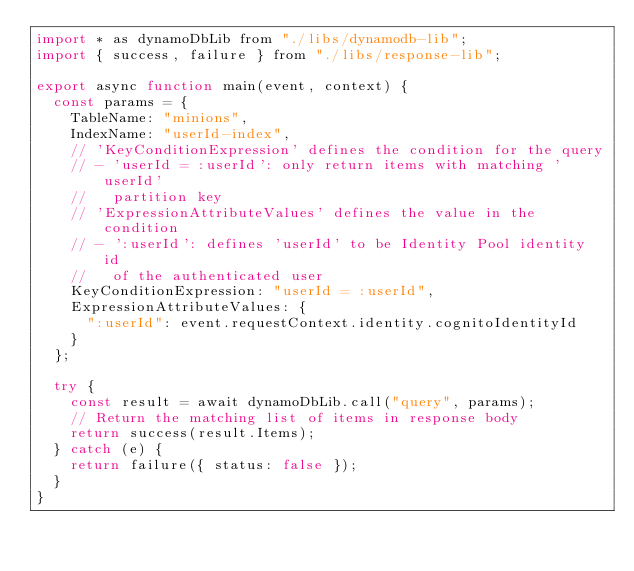<code> <loc_0><loc_0><loc_500><loc_500><_JavaScript_>import * as dynamoDbLib from "./libs/dynamodb-lib";
import { success, failure } from "./libs/response-lib";

export async function main(event, context) {
  const params = {
    TableName: "minions",
    IndexName: "userId-index",
    // 'KeyConditionExpression' defines the condition for the query
    // - 'userId = :userId': only return items with matching 'userId'
    //   partition key
    // 'ExpressionAttributeValues' defines the value in the condition
    // - ':userId': defines 'userId' to be Identity Pool identity id
    //   of the authenticated user
    KeyConditionExpression: "userId = :userId",
    ExpressionAttributeValues: {
      ":userId": event.requestContext.identity.cognitoIdentityId
    }
  };

  try {
    const result = await dynamoDbLib.call("query", params);
    // Return the matching list of items in response body
    return success(result.Items);
  } catch (e) {
    return failure({ status: false });
  }
}
</code> 